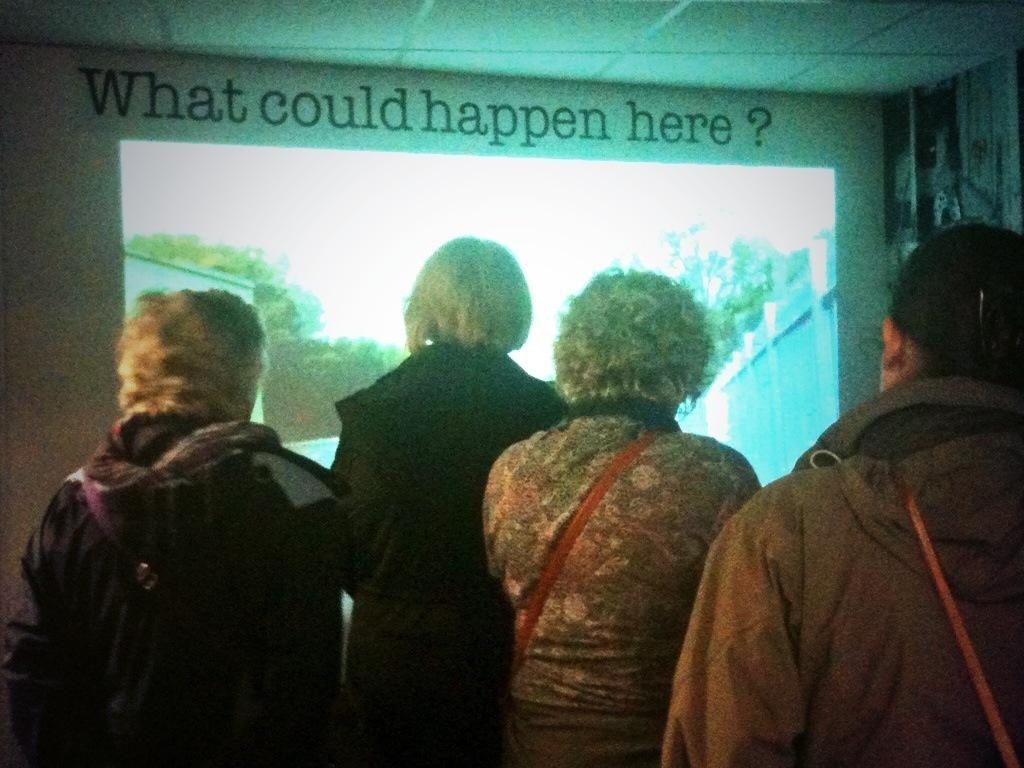What can be seen in the image? There are people standing in the image. Where are the people standing? The people are standing on the floor. What is visible in the background of the image? There is a display screen in the background of the image. What type of amusement can be seen in the image? There is no amusement present in the image; it features people standing on the floor with a display screen in the background. Is there a plough visible in the image? There is no plough present in the image. 